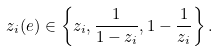Convert formula to latex. <formula><loc_0><loc_0><loc_500><loc_500>z _ { i } ( e ) \in \left \{ z _ { i } , \frac { 1 } { 1 - z _ { i } } , 1 - \frac { 1 } { z _ { i } } \right \} .</formula> 